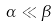<formula> <loc_0><loc_0><loc_500><loc_500>\alpha \ll \beta</formula> 